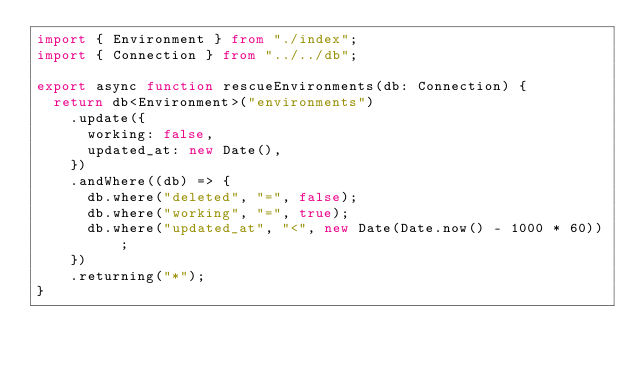<code> <loc_0><loc_0><loc_500><loc_500><_TypeScript_>import { Environment } from "./index";
import { Connection } from "../../db";

export async function rescueEnvironments(db: Connection) {
  return db<Environment>("environments")
    .update({
      working: false,
      updated_at: new Date(),
    })
    .andWhere((db) => {
      db.where("deleted", "=", false);
      db.where("working", "=", true);
      db.where("updated_at", "<", new Date(Date.now() - 1000 * 60));
    })
    .returning("*");
}
</code> 